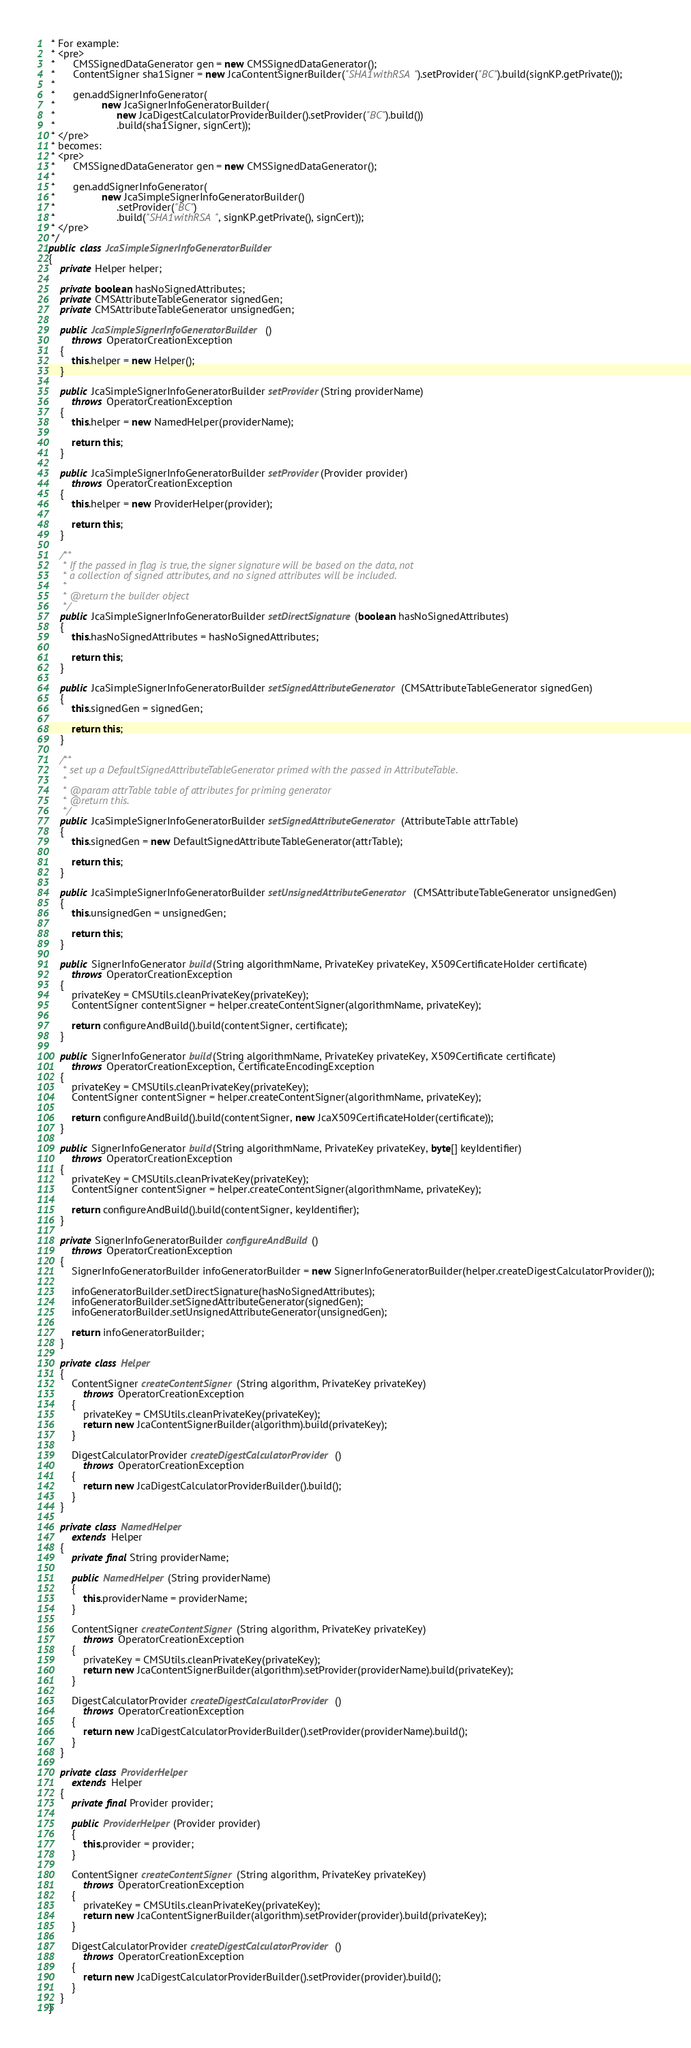<code> <loc_0><loc_0><loc_500><loc_500><_Java_> * For example:
 * <pre>
 *      CMSSignedDataGenerator gen = new CMSSignedDataGenerator();
 *      ContentSigner sha1Signer = new JcaContentSignerBuilder("SHA1withRSA").setProvider("BC").build(signKP.getPrivate());
 *
 *      gen.addSignerInfoGenerator(
 *                new JcaSignerInfoGeneratorBuilder(
 *                     new JcaDigestCalculatorProviderBuilder().setProvider("BC").build())
 *                     .build(sha1Signer, signCert));
 * </pre>
 * becomes:
 * <pre>
 *      CMSSignedDataGenerator gen = new CMSSignedDataGenerator();
 *
 *      gen.addSignerInfoGenerator(
 *                new JcaSimpleSignerInfoGeneratorBuilder()
 *                     .setProvider("BC")
 *                     .build("SHA1withRSA", signKP.getPrivate(), signCert));
 * </pre>
 */
public class JcaSimpleSignerInfoGeneratorBuilder
{
    private Helper helper;

    private boolean hasNoSignedAttributes;
    private CMSAttributeTableGenerator signedGen;
    private CMSAttributeTableGenerator unsignedGen;

    public JcaSimpleSignerInfoGeneratorBuilder()
        throws OperatorCreationException
    {
        this.helper = new Helper();
    }

    public JcaSimpleSignerInfoGeneratorBuilder setProvider(String providerName)
        throws OperatorCreationException
    {
        this.helper = new NamedHelper(providerName);

        return this;
    }

    public JcaSimpleSignerInfoGeneratorBuilder setProvider(Provider provider)
        throws OperatorCreationException
    {
        this.helper = new ProviderHelper(provider);

        return this;
    }

    /**
     * If the passed in flag is true, the signer signature will be based on the data, not
     * a collection of signed attributes, and no signed attributes will be included.
     *
     * @return the builder object
     */
    public JcaSimpleSignerInfoGeneratorBuilder setDirectSignature(boolean hasNoSignedAttributes)
    {
        this.hasNoSignedAttributes = hasNoSignedAttributes;

        return this;
    }

    public JcaSimpleSignerInfoGeneratorBuilder setSignedAttributeGenerator(CMSAttributeTableGenerator signedGen)
    {
        this.signedGen = signedGen;

        return this;
    }

    /**
     * set up a DefaultSignedAttributeTableGenerator primed with the passed in AttributeTable.
     *
     * @param attrTable table of attributes for priming generator
     * @return this.
     */
    public JcaSimpleSignerInfoGeneratorBuilder setSignedAttributeGenerator(AttributeTable attrTable)
    {
        this.signedGen = new DefaultSignedAttributeTableGenerator(attrTable);

        return this;
    }

    public JcaSimpleSignerInfoGeneratorBuilder setUnsignedAttributeGenerator(CMSAttributeTableGenerator unsignedGen)
    {
        this.unsignedGen = unsignedGen;

        return this;
    }

    public SignerInfoGenerator build(String algorithmName, PrivateKey privateKey, X509CertificateHolder certificate)
        throws OperatorCreationException
    {
        privateKey = CMSUtils.cleanPrivateKey(privateKey);
        ContentSigner contentSigner = helper.createContentSigner(algorithmName, privateKey);

        return configureAndBuild().build(contentSigner, certificate);
    }

    public SignerInfoGenerator build(String algorithmName, PrivateKey privateKey, X509Certificate certificate)
        throws OperatorCreationException, CertificateEncodingException
    {
        privateKey = CMSUtils.cleanPrivateKey(privateKey);
        ContentSigner contentSigner = helper.createContentSigner(algorithmName, privateKey);

        return configureAndBuild().build(contentSigner, new JcaX509CertificateHolder(certificate));
    }

    public SignerInfoGenerator build(String algorithmName, PrivateKey privateKey, byte[] keyIdentifier)
        throws OperatorCreationException
    {
        privateKey = CMSUtils.cleanPrivateKey(privateKey);
        ContentSigner contentSigner = helper.createContentSigner(algorithmName, privateKey);

        return configureAndBuild().build(contentSigner, keyIdentifier);
    }

    private SignerInfoGeneratorBuilder configureAndBuild()
        throws OperatorCreationException
    {
        SignerInfoGeneratorBuilder infoGeneratorBuilder = new SignerInfoGeneratorBuilder(helper.createDigestCalculatorProvider());

        infoGeneratorBuilder.setDirectSignature(hasNoSignedAttributes);
        infoGeneratorBuilder.setSignedAttributeGenerator(signedGen);
        infoGeneratorBuilder.setUnsignedAttributeGenerator(unsignedGen);

        return infoGeneratorBuilder;
    }

    private class Helper
    {
        ContentSigner createContentSigner(String algorithm, PrivateKey privateKey)
            throws OperatorCreationException
        {
            privateKey = CMSUtils.cleanPrivateKey(privateKey);
            return new JcaContentSignerBuilder(algorithm).build(privateKey);
        }

        DigestCalculatorProvider createDigestCalculatorProvider()
            throws OperatorCreationException
        {
            return new JcaDigestCalculatorProviderBuilder().build();
        }
    }

    private class NamedHelper
        extends Helper
    {
        private final String providerName;

        public NamedHelper(String providerName)
        {
            this.providerName = providerName;
        }

        ContentSigner createContentSigner(String algorithm, PrivateKey privateKey)
            throws OperatorCreationException
        {
            privateKey = CMSUtils.cleanPrivateKey(privateKey);
            return new JcaContentSignerBuilder(algorithm).setProvider(providerName).build(privateKey);
        }

        DigestCalculatorProvider createDigestCalculatorProvider()
            throws OperatorCreationException
        {
            return new JcaDigestCalculatorProviderBuilder().setProvider(providerName).build();
        }
    }

    private class ProviderHelper
        extends Helper
    {
        private final Provider provider;

        public ProviderHelper(Provider provider)
        {
            this.provider = provider;
        }

        ContentSigner createContentSigner(String algorithm, PrivateKey privateKey)
            throws OperatorCreationException
        {
            privateKey = CMSUtils.cleanPrivateKey(privateKey);
            return new JcaContentSignerBuilder(algorithm).setProvider(provider).build(privateKey);
        }

        DigestCalculatorProvider createDigestCalculatorProvider()
            throws OperatorCreationException
        {
            return new JcaDigestCalculatorProviderBuilder().setProvider(provider).build();
        }
    }
}
</code> 